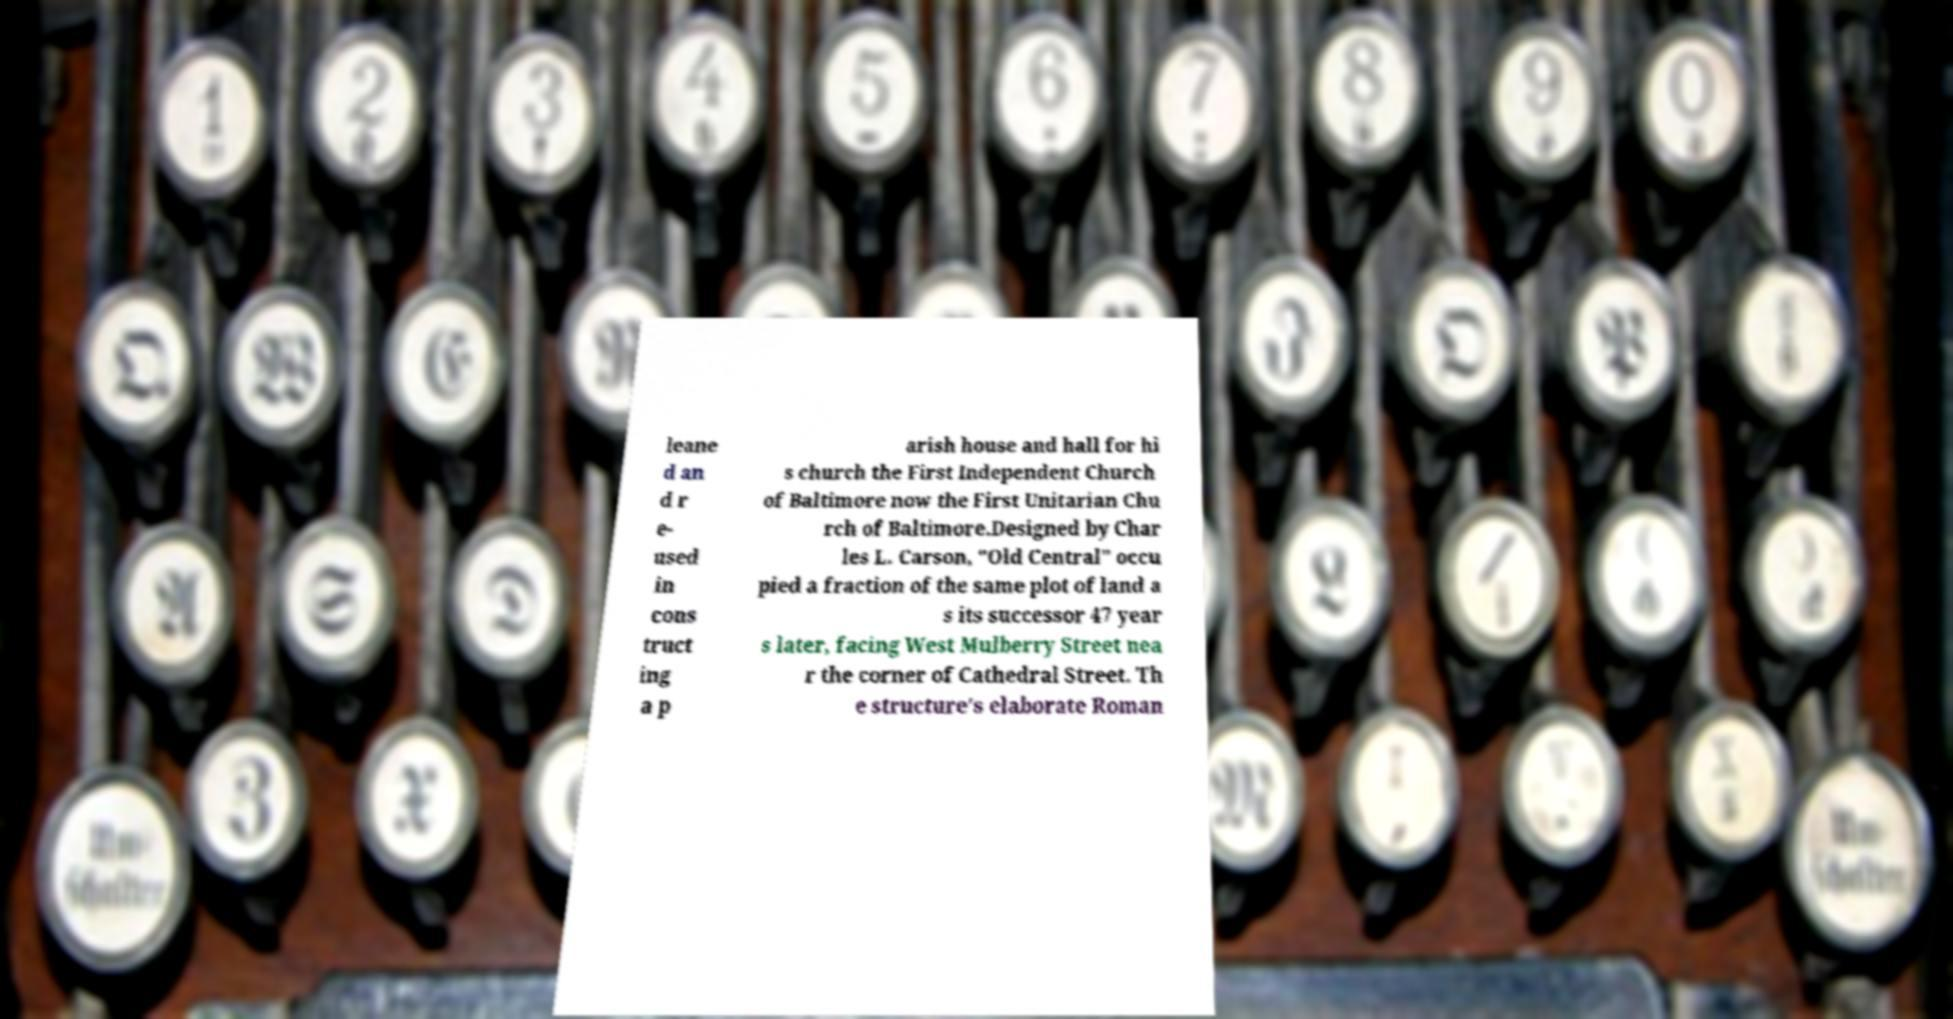Can you read and provide the text displayed in the image?This photo seems to have some interesting text. Can you extract and type it out for me? leane d an d r e- used in cons truct ing a p arish house and hall for hi s church the First Independent Church of Baltimore now the First Unitarian Chu rch of Baltimore.Designed by Char les L. Carson, "Old Central" occu pied a fraction of the same plot of land a s its successor 47 year s later, facing West Mulberry Street nea r the corner of Cathedral Street. Th e structure's elaborate Roman 